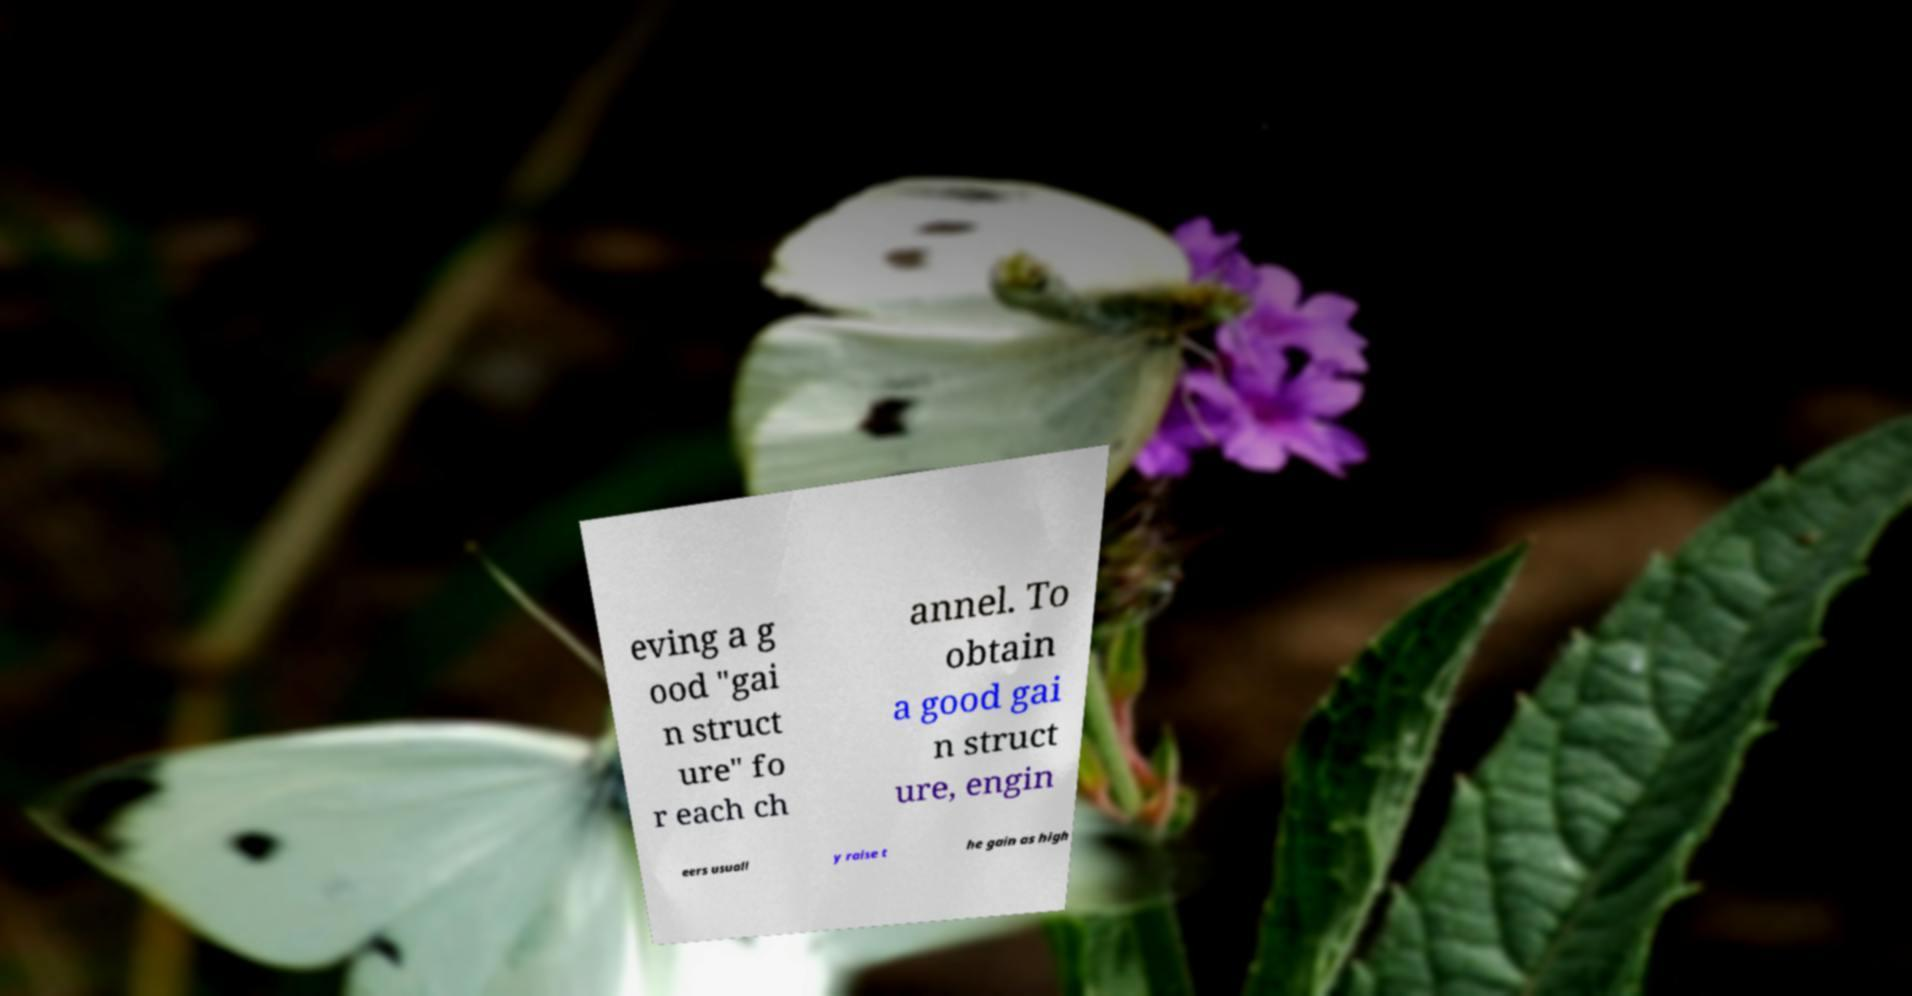For documentation purposes, I need the text within this image transcribed. Could you provide that? eving a g ood "gai n struct ure" fo r each ch annel. To obtain a good gai n struct ure, engin eers usuall y raise t he gain as high 